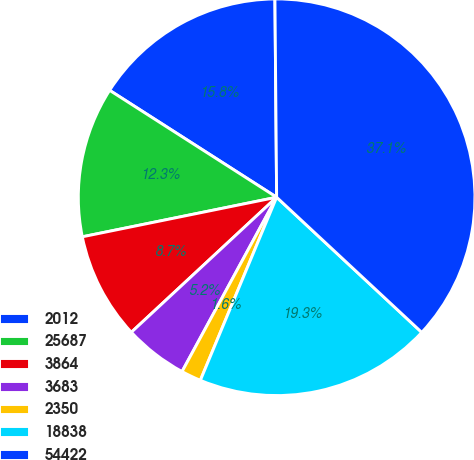<chart> <loc_0><loc_0><loc_500><loc_500><pie_chart><fcel>2012<fcel>25687<fcel>3864<fcel>3683<fcel>2350<fcel>18838<fcel>54422<nl><fcel>15.8%<fcel>12.26%<fcel>8.72%<fcel>5.17%<fcel>1.63%<fcel>19.35%<fcel>37.07%<nl></chart> 